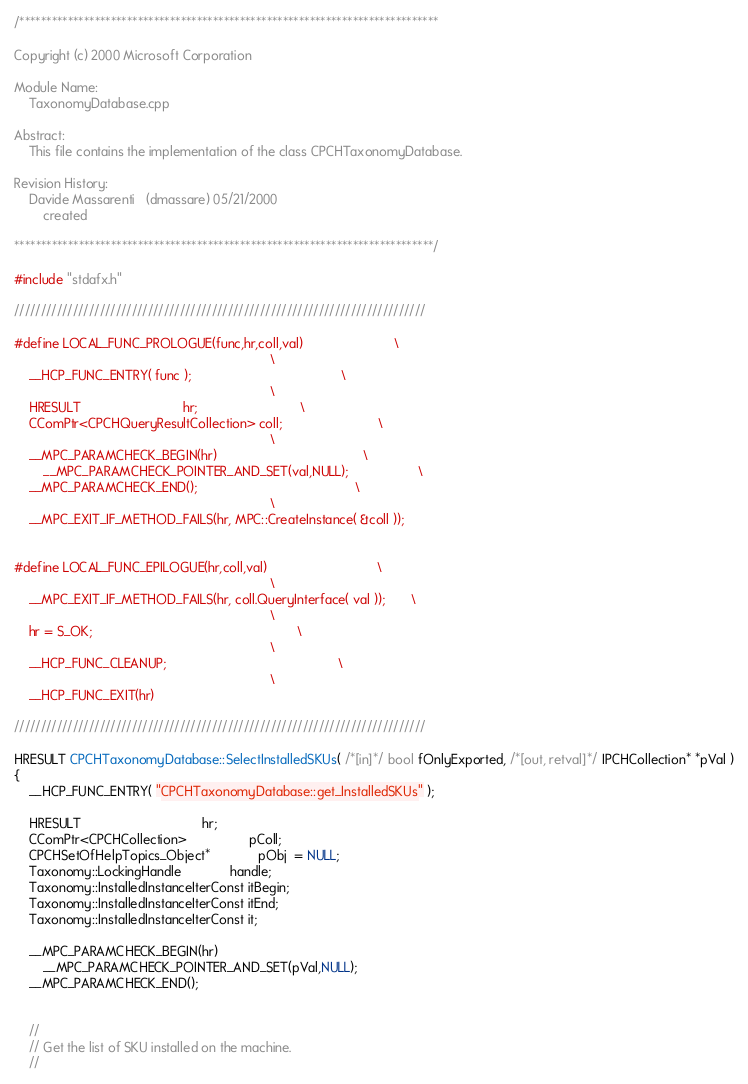Convert code to text. <code><loc_0><loc_0><loc_500><loc_500><_C++_>/******************************************************************************

Copyright (c) 2000 Microsoft Corporation

Module Name:
    TaxonomyDatabase.cpp

Abstract:
    This file contains the implementation of the class CPCHTaxonomyDatabase.

Revision History:
    Davide Massarenti   (dmassare) 05/21/2000
        created

******************************************************************************/

#include "stdafx.h"

/////////////////////////////////////////////////////////////////////////////

#define LOCAL_FUNC_PROLOGUE(func,hr,coll,val)                         \
                                                                      \
    __HCP_FUNC_ENTRY( func );                                         \
                                                                      \
    HRESULT                            hr;                            \
    CComPtr<CPCHQueryResultCollection> coll;                          \
                                                                      \
    __MPC_PARAMCHECK_BEGIN(hr)                                        \
        __MPC_PARAMCHECK_POINTER_AND_SET(val,NULL);                   \
    __MPC_PARAMCHECK_END();                                           \
                                                                      \
    __MPC_EXIT_IF_METHOD_FAILS(hr, MPC::CreateInstance( &coll ));	  
																	  
																	  
#define LOCAL_FUNC_EPILOGUE(hr,coll,val)                              \
                                                                      \
    __MPC_EXIT_IF_METHOD_FAILS(hr, coll.QueryInterface( val ));       \
                                                                      \
    hr = S_OK;                                                        \
                                                                      \
    __HCP_FUNC_CLEANUP;                                               \
                                                                      \
    __HCP_FUNC_EXIT(hr)

/////////////////////////////////////////////////////////////////////////////

HRESULT CPCHTaxonomyDatabase::SelectInstalledSKUs( /*[in]*/ bool fOnlyExported, /*[out, retval]*/ IPCHCollection* *pVal )
{
    __HCP_FUNC_ENTRY( "CPCHTaxonomyDatabase::get_InstalledSKUs" );

    HRESULT                    			 hr;
    CComPtr<CPCHCollection>    			 pColl;
    CPCHSetOfHelpTopics_Object*			 pObj  = NULL;
	Taxonomy::LockingHandle  			 handle;
	Taxonomy::InstalledInstanceIterConst itBegin;
	Taxonomy::InstalledInstanceIterConst itEnd;
	Taxonomy::InstalledInstanceIterConst it;

    __MPC_PARAMCHECK_BEGIN(hr)
        __MPC_PARAMCHECK_POINTER_AND_SET(pVal,NULL);
    __MPC_PARAMCHECK_END();


    //
    // Get the list of SKU installed on the machine.
    //</code> 